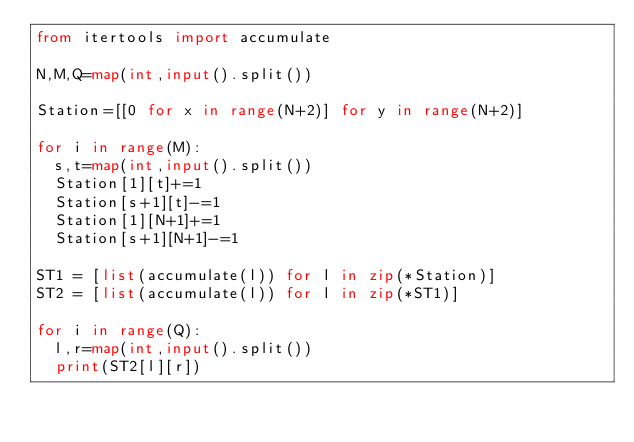<code> <loc_0><loc_0><loc_500><loc_500><_Python_>from itertools import accumulate

N,M,Q=map(int,input().split())

Station=[[0 for x in range(N+2)] for y in range(N+2)]

for i in range(M):
  s,t=map(int,input().split())
  Station[1][t]+=1
  Station[s+1][t]-=1
  Station[1][N+1]+=1
  Station[s+1][N+1]-=1

ST1 = [list(accumulate(l)) for l in zip(*Station)]
ST2 = [list(accumulate(l)) for l in zip(*ST1)]
  
for i in range(Q):
  l,r=map(int,input().split())
  print(ST2[l][r])
  
  
  </code> 